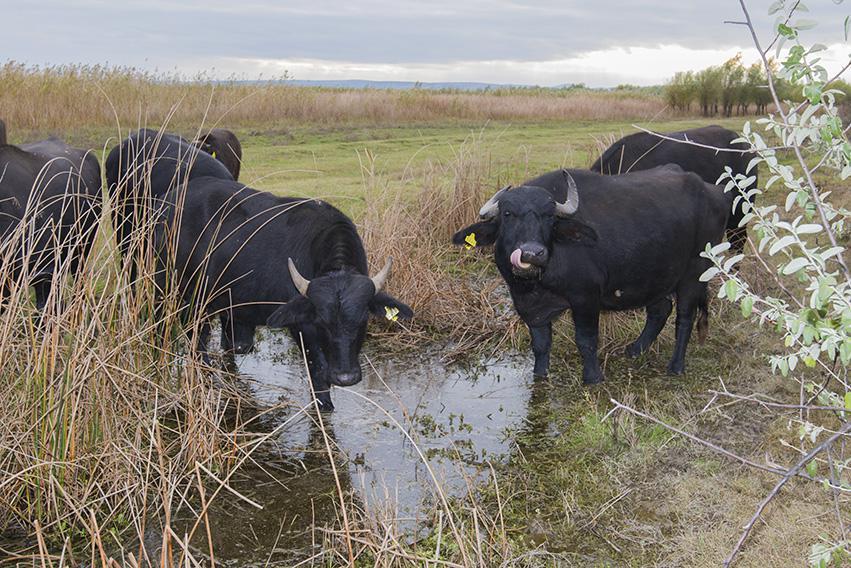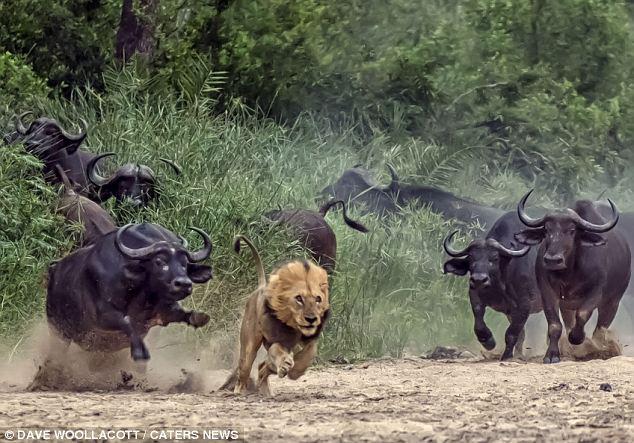The first image is the image on the left, the second image is the image on the right. Considering the images on both sides, is "water buffalo are at the water hole" valid? Answer yes or no. Yes. The first image is the image on the left, the second image is the image on the right. Analyze the images presented: Is the assertion "There are no more than six water buffaloes in the left image." valid? Answer yes or no. Yes. 